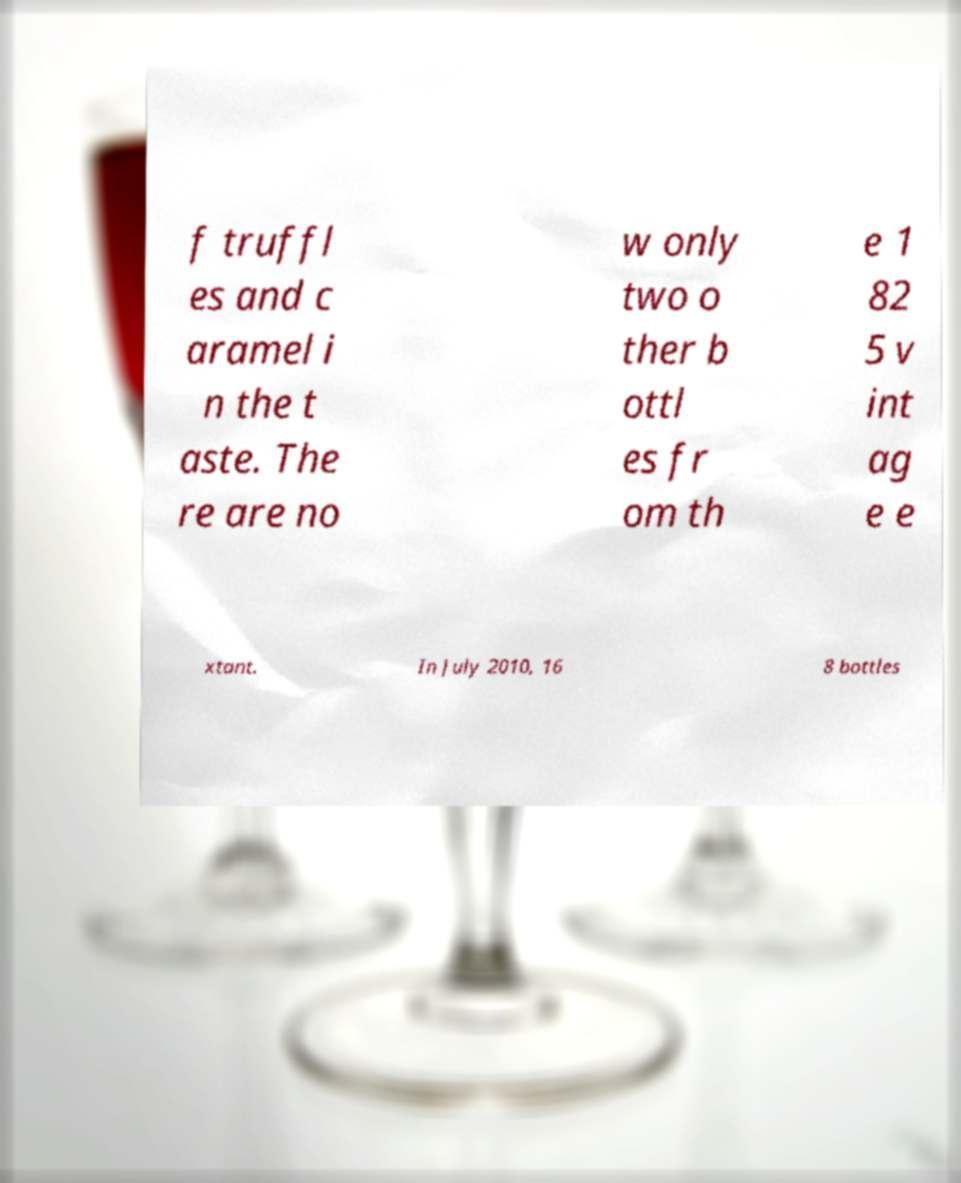There's text embedded in this image that I need extracted. Can you transcribe it verbatim? f truffl es and c aramel i n the t aste. The re are no w only two o ther b ottl es fr om th e 1 82 5 v int ag e e xtant. In July 2010, 16 8 bottles 